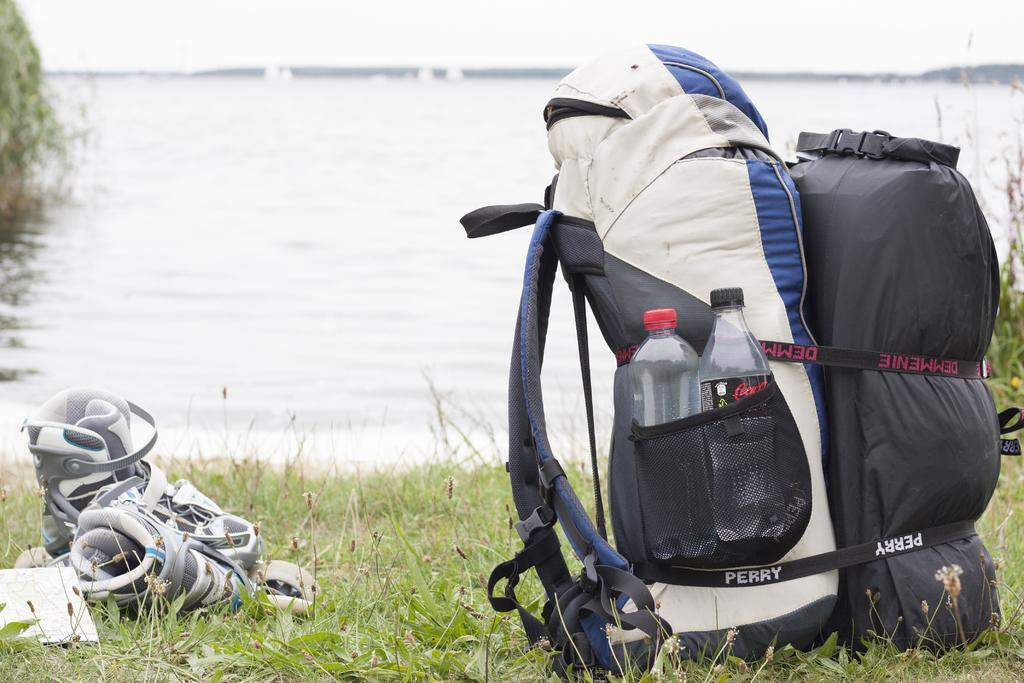What type of bag is visible in the image? There is a travel bag pack in the image. What else is on the ground in the image? There are pair of shoes on the ground in the image. What is the ground covered with? The ground is covered with grass. What can be seen on the other side of the image? There is a river on the other side of the image. Can you read the note that the crow is holding in the image? There is no note or crow present in the image. How does the river show respect to the travel bag pack in the image? The river does not show respect to the travel bag pack in the image; it is a natural feature and does not have the ability to show respect. 